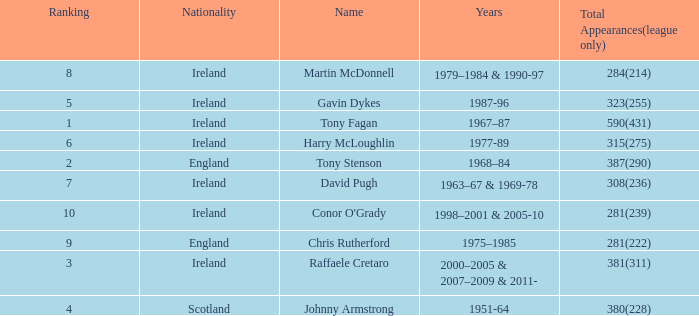How many total appearances (league only) have a name of gavin dykes? 323(255). 